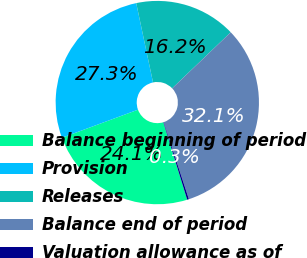Convert chart. <chart><loc_0><loc_0><loc_500><loc_500><pie_chart><fcel>Balance beginning of period<fcel>Provision<fcel>Releases<fcel>Balance end of period<fcel>Valuation allowance as of<nl><fcel>24.12%<fcel>27.3%<fcel>16.17%<fcel>32.12%<fcel>0.28%<nl></chart> 